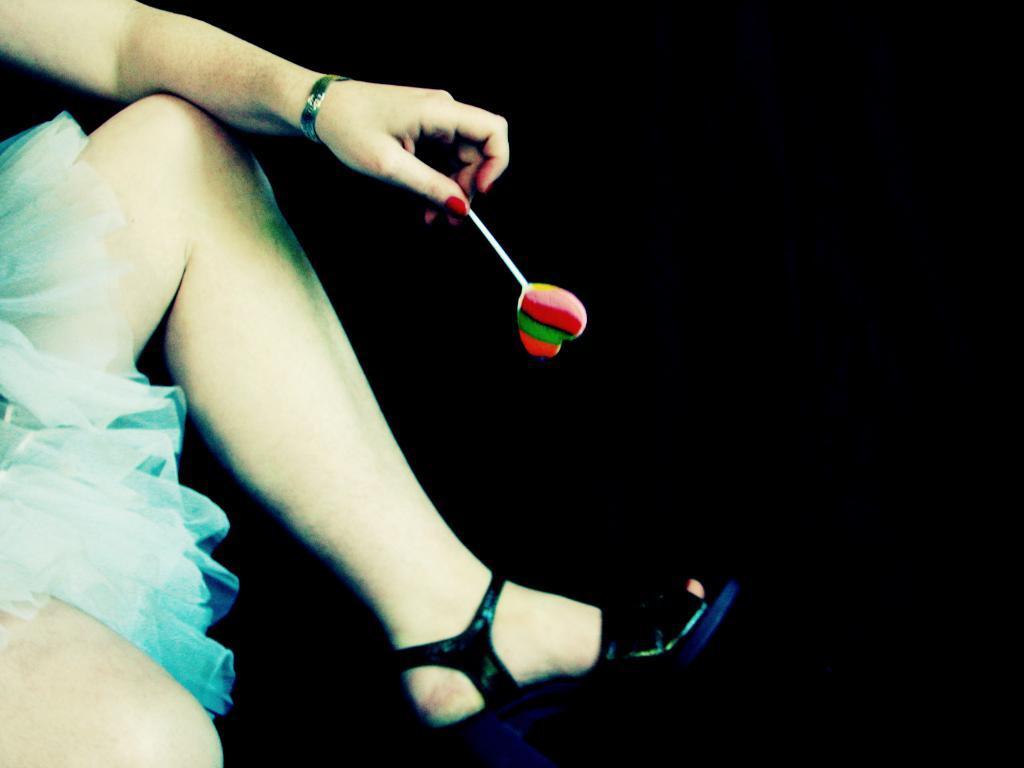Please provide a concise description of this image. In this picture, we see the woman in the blue dress is wearing the black sandals. She is holding a lollipop in her hand. In the background, it is black in color. 